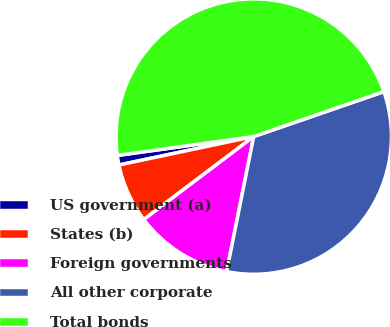Convert chart. <chart><loc_0><loc_0><loc_500><loc_500><pie_chart><fcel>US government (a)<fcel>States (b)<fcel>Foreign governments<fcel>All other corporate<fcel>Total bonds<nl><fcel>1.12%<fcel>6.98%<fcel>11.56%<fcel>33.44%<fcel>46.9%<nl></chart> 